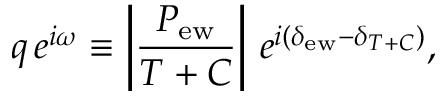Convert formula to latex. <formula><loc_0><loc_0><loc_500><loc_500>q \, e ^ { i \omega } \equiv \left | \frac { P _ { e w } } { T + C } \right | \, e ^ { i ( \delta _ { e w } - \delta _ { T + C } ) } ,</formula> 